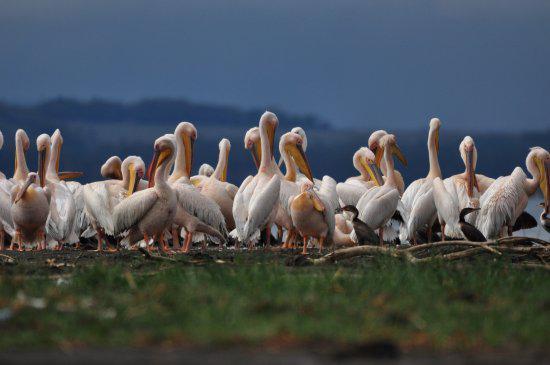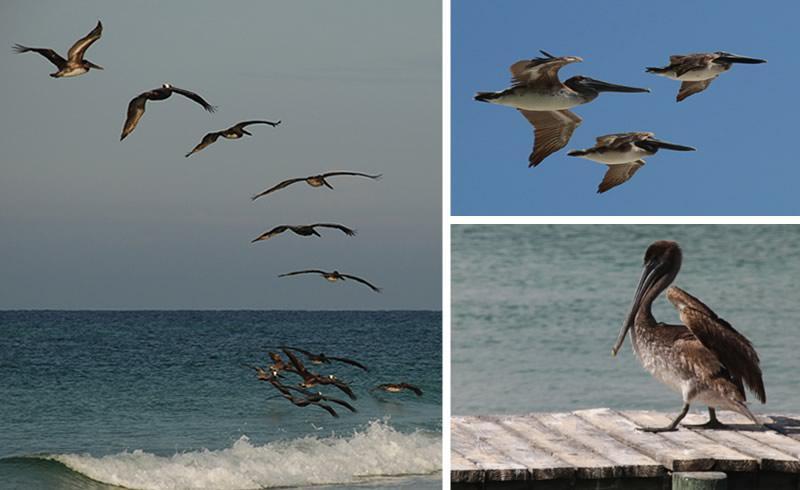The first image is the image on the left, the second image is the image on the right. Examine the images to the left and right. Is the description "At least two birds are flying." accurate? Answer yes or no. Yes. The first image is the image on the left, the second image is the image on the right. For the images shown, is this caption "Left image shows a pelican perched on a structure in the foreground." true? Answer yes or no. No. 